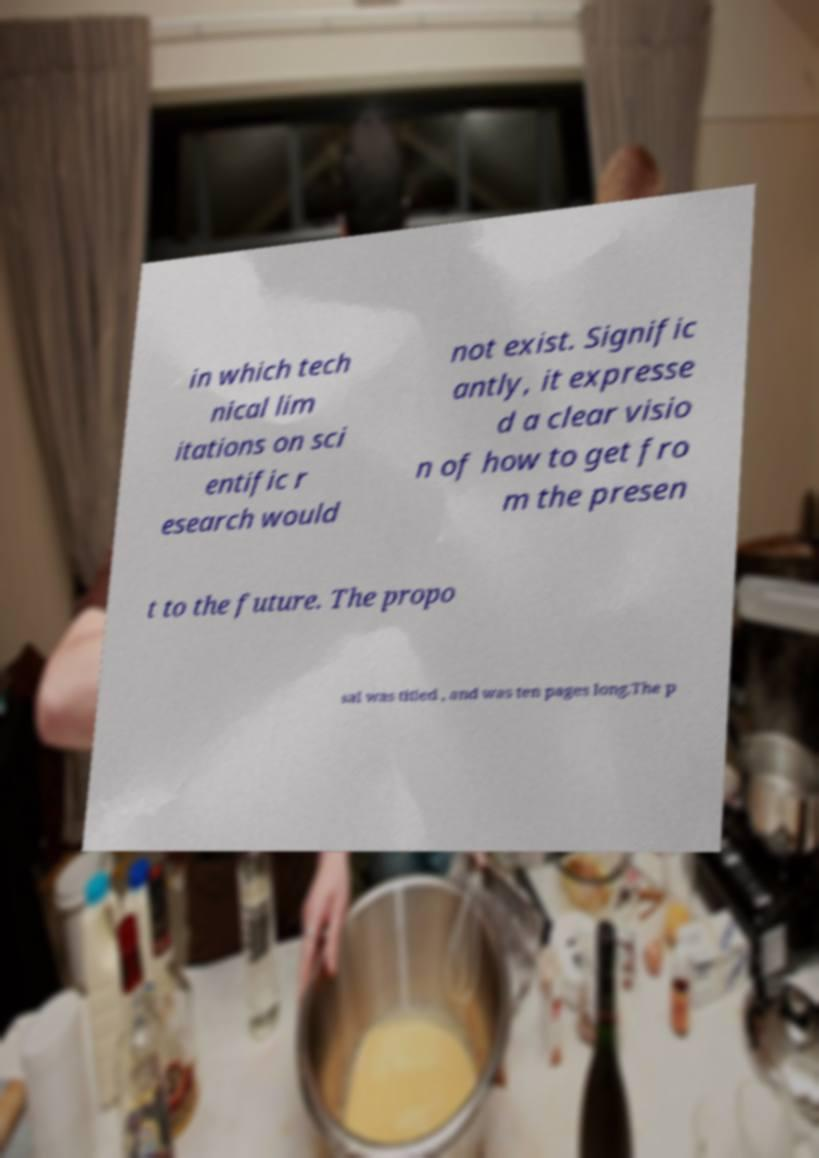Please read and relay the text visible in this image. What does it say? in which tech nical lim itations on sci entific r esearch would not exist. Signific antly, it expresse d a clear visio n of how to get fro m the presen t to the future. The propo sal was titled , and was ten pages long.The p 